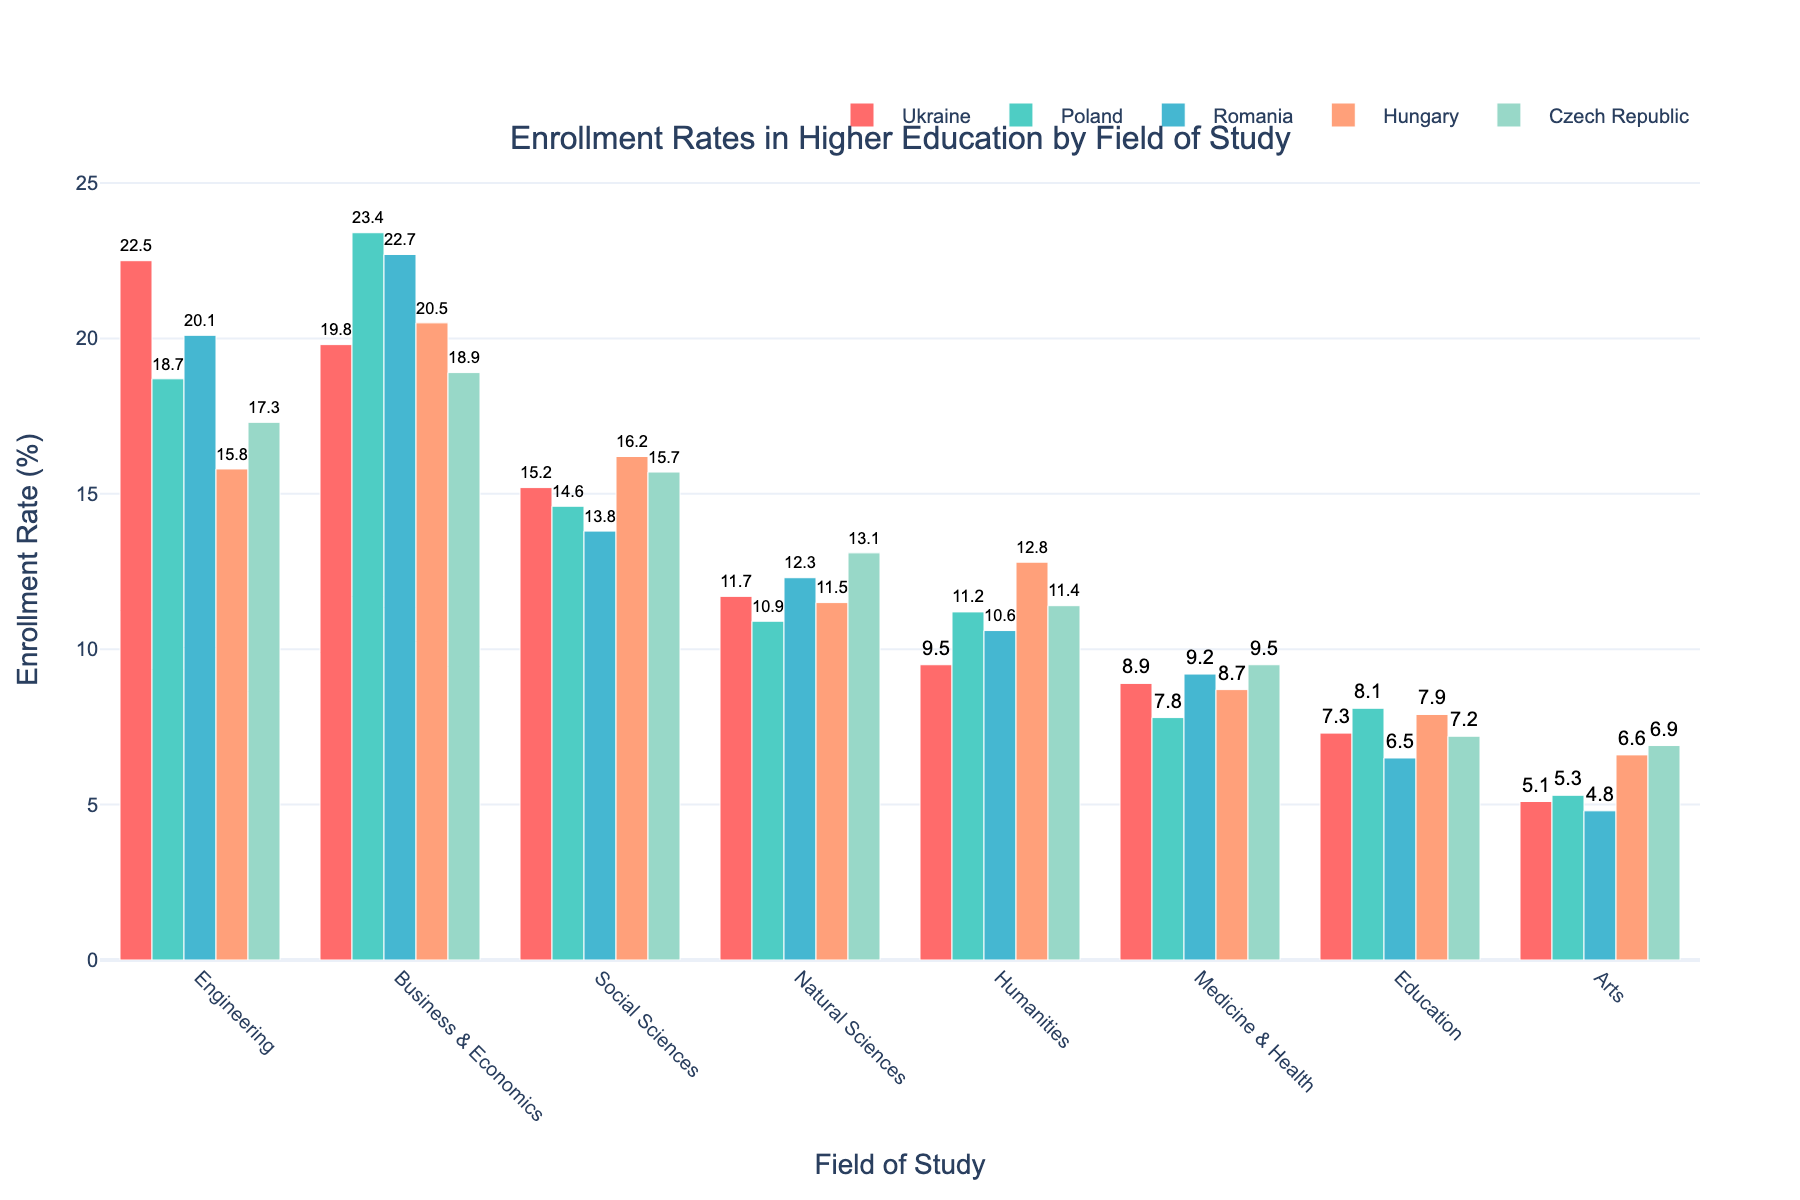What field of study has the highest enrollment rate in Poland? Look at the bars for Poland and identify the tallest one. It is Business & Economics with 23.4%.
Answer: Business & Economics Which country has the lowest enrollment rate for Arts? Examine the bars for the Arts field and identify the shortest one among the five countries. Romania has the lowest rate at 4.8%.
Answer: Romania What is the total enrollment rate for Social Sciences in all five countries? Add the enrollment rates for Social Sciences across all countries: Ukraine (15.2) + Poland (14.6) + Romania (13.8) + Hungary (16.2) + Czech Republic (15.7) = 75.5.
Answer: 75.5% Which two countries have the closest enrollment rates for Engineering? Compare the bars for Engineering across all countries. Poland (18.7) and Czech Republic (17.3) have the closest rates, differing by just 1.4 percentage points.
Answer: Poland and Czech Republic In which country do Medicine & Health and Natural Sciences have nearly identical enrollment rates? Compare the bars for Medicine & Health and Natural Sciences in each country. Czech Republic has rates of 9.5% and 13.1%, which are close.
Answer: Czech Republic What's the difference in enrollment rates for Natural Sciences between Ukraine and Poland? Subtract the enrollment rate of Natural Sciences in Poland (10.9) from that in Ukraine (11.7): 11.7 - 10.9 = 0.8.
Answer: 0.8% Which country has a higher enrollment rate in Humanities, Hungary or Poland? Compare the bars for Humanities between Hungary (12.8) and Poland (11.2). Hungary has a higher enrollment rate.
Answer: Hungary What's the average enrollment rate for Business & Economics across all countries? Divide the total of enrollment rates for Business & Economics by the number of countries: (19.8 + 23.4 + 22.7 + 20.5 + 18.9) / 5 = 105.3 / 5 = 21.06.
Answer: 21.06% Which field of study has the smallest variation in enrollment rates across the countries? Look for the field where the bars are most similar in height across all countries. Education has the smallest variations: Ukraine (7.3), Poland (8.1), Romania (6.5), Hungary (7.9), Czech Republic (7.2).
Answer: Education If the enrollment rate in Social Sciences in Romania increased by 2%, would it be higher than the rate in Czech Republic? Currently, Romania has an enrollment rate of 13.8% for Social Sciences. If it increases by 2%, it becomes 15.8%. Compare this to Czech Republic's 15.7%. Yes, it would be higher.
Answer: Yes 